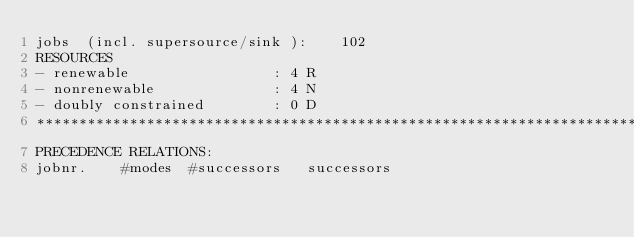<code> <loc_0><loc_0><loc_500><loc_500><_ObjectiveC_>jobs  (incl. supersource/sink ):	102
RESOURCES
- renewable                 : 4 R
- nonrenewable              : 4 N
- doubly constrained        : 0 D
************************************************************************
PRECEDENCE RELATIONS:
jobnr.    #modes  #successors   successors</code> 